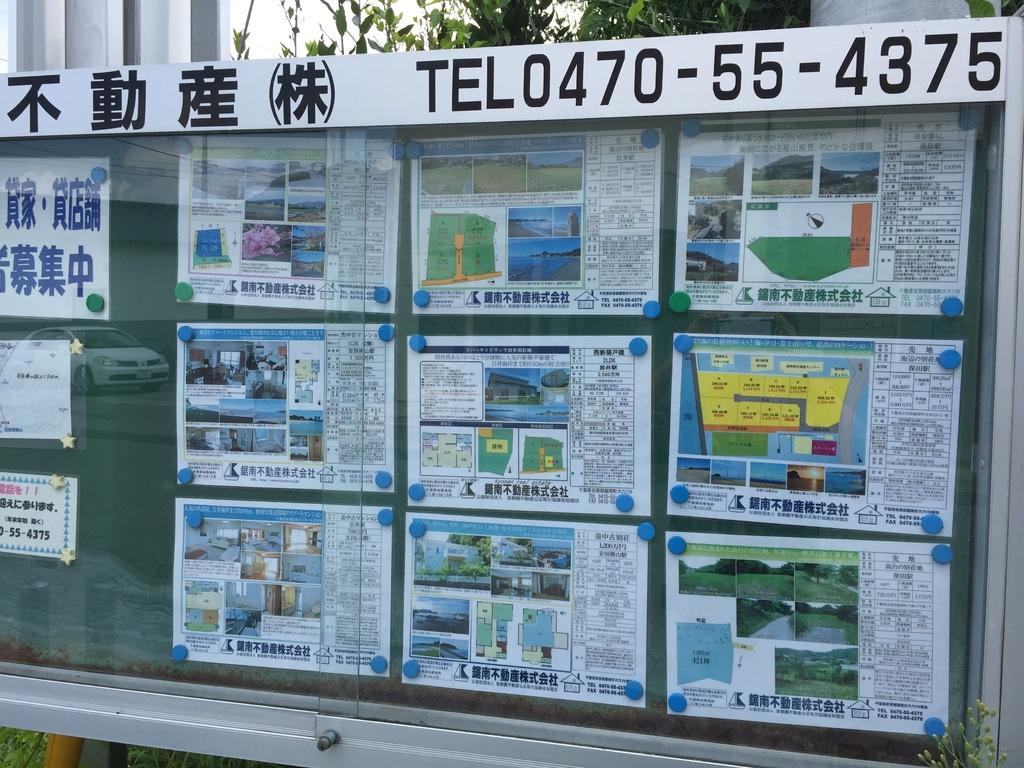Provide a one-sentence caption for the provided image. An outdoor display showing homes for sale with a number to call of TEL0470-55-4375. 